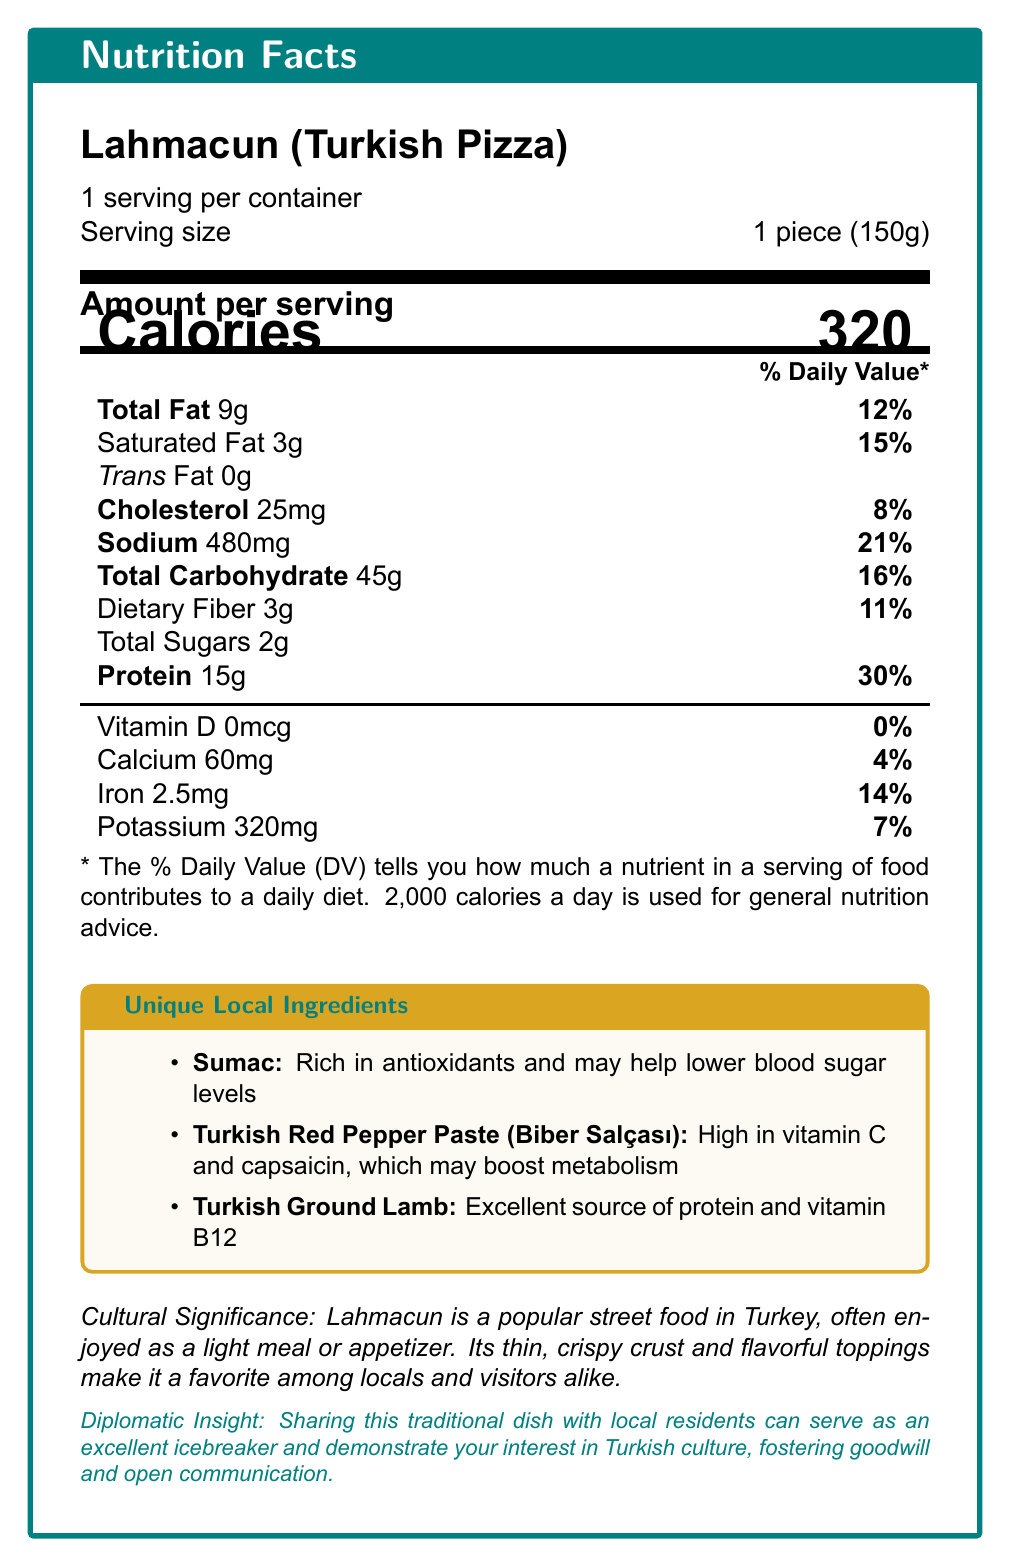what is the serving size of Lahmacun? The document specifies that the serving size is 1 piece, which weighs 150 grams.
Answer: 1 piece (150g) how many calories are in one serving of Lahmacun? The document indicates that one serving contains 320 calories.
Answer: 320 what unique local ingredient in Lahmacun is high in vitamin C? The document states that Turkish Red Pepper Paste is high in vitamin C and capsaicin.
Answer: Turkish Red Pepper Paste (Biber Salçası) what percentage of daily iron requirement is met by one serving of this dish? The document mentions that one serving of Lahmacun provides 14% of the daily value for iron.
Answer: 14% which ingredient is beneficial for lowering blood sugar levels? According to the document, Sumac is rich in antioxidants and may help lower blood sugar levels.
Answer: Sumac what is the total fat content per serving? A. 9g B. 15g C. 25mg The document lists the total fat content as 9g per serving.
Answer: A. 9g how much protein is in a serving of Lahmacun? A. 15g B. 9g C. 25mg The document specifies that one serving contains 15g of protein.
Answer: A. 15g is this dish a good source of dietary fiber? The document indicates that one serving provides 3g of dietary fiber, which is 11% of the daily value.
Answer: Yes describe the entire document in one sentence. The document includes detailed nutritional information, the significance of local ingredients, and insights into the cultural importance of the dish.
Answer: The document provides the nutrition facts for Lahmacun (Turkish Pizza), highlighting its nutritional content, unique local ingredients, their benefits, and cultural significance. is there enough information to determine if Lahmacun is suitable for someone with a gluten allergy? The document does not provide information about gluten content or ingredients that may contain gluten, so it's not possible to determine if Lahmacun is suitable for someone with a gluten allergy.
Answer: Not enough information 